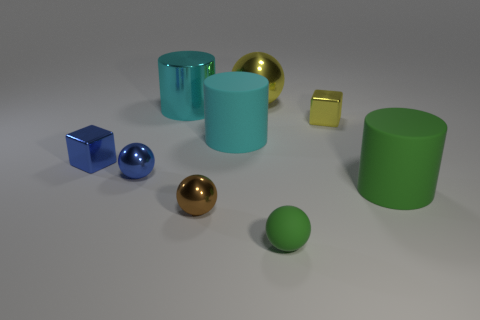Subtract 1 balls. How many balls are left? 3 Subtract all small spheres. How many spheres are left? 1 Add 1 blocks. How many objects exist? 10 Subtract all yellow spheres. How many spheres are left? 3 Subtract all purple balls. Subtract all red cylinders. How many balls are left? 4 Subtract all cylinders. How many objects are left? 6 Subtract 1 green balls. How many objects are left? 8 Subtract all blue balls. Subtract all small blue things. How many objects are left? 6 Add 4 large yellow metal objects. How many large yellow metal objects are left? 5 Add 1 metal blocks. How many metal blocks exist? 3 